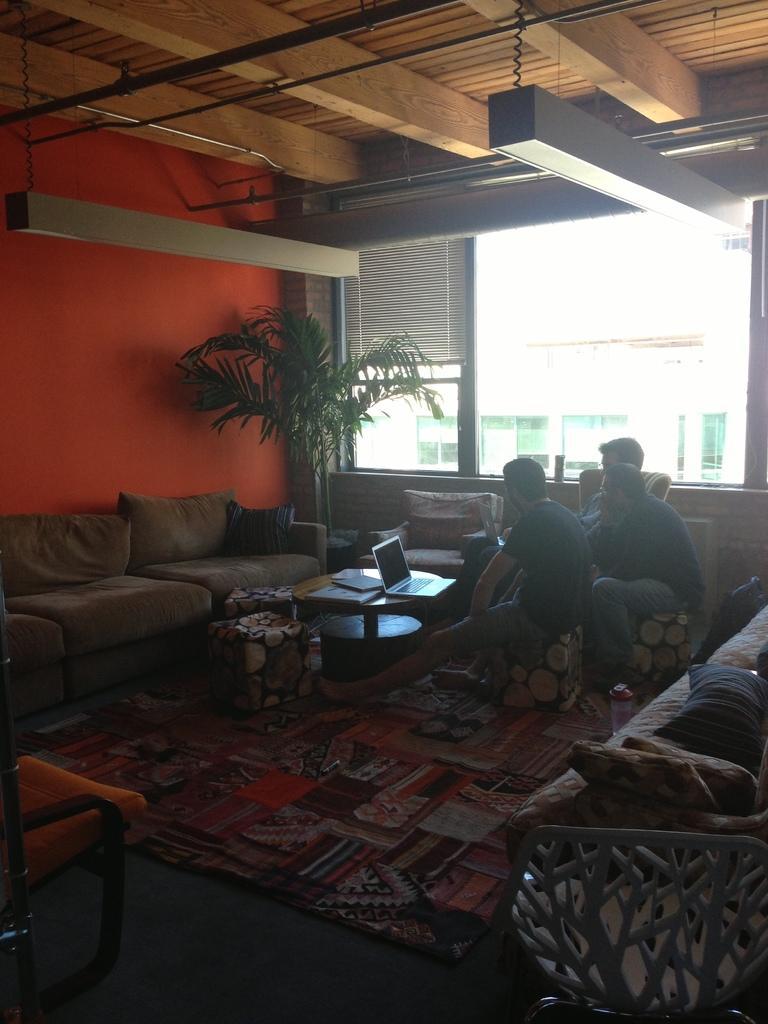Could you give a brief overview of what you see in this image? This picture is clicked inside the room. In the center we can see the group of persons sitting and we can see a laptop and some other objects are placed on the top of the center table and we can see the floor mat, chairs, sofas, cushions and some other objects. In the background we can see the window, window blind, house plant. At the top we can see the roof and the lights hanging on the roof and through the windows we can see the outside view, we can see some other objects. 